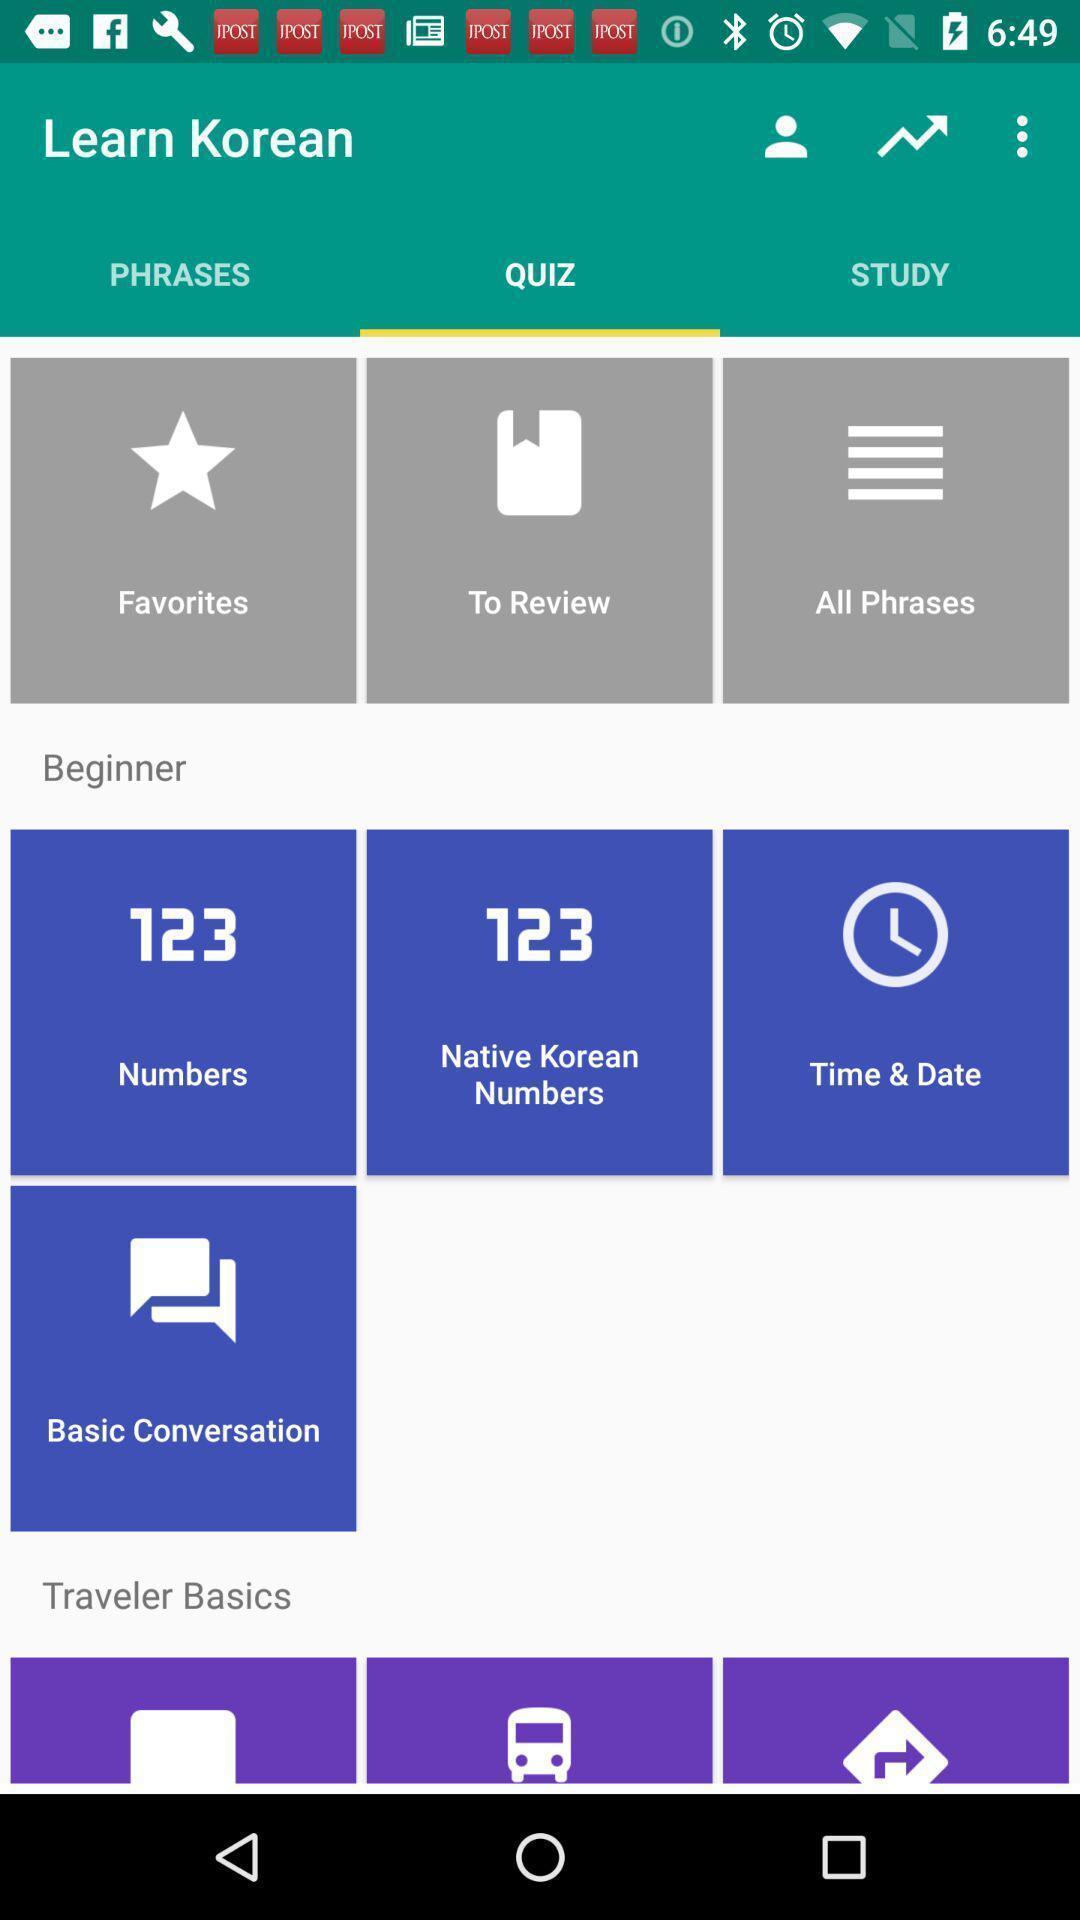Summarize the main components in this picture. Screen displaying the quiz page. 